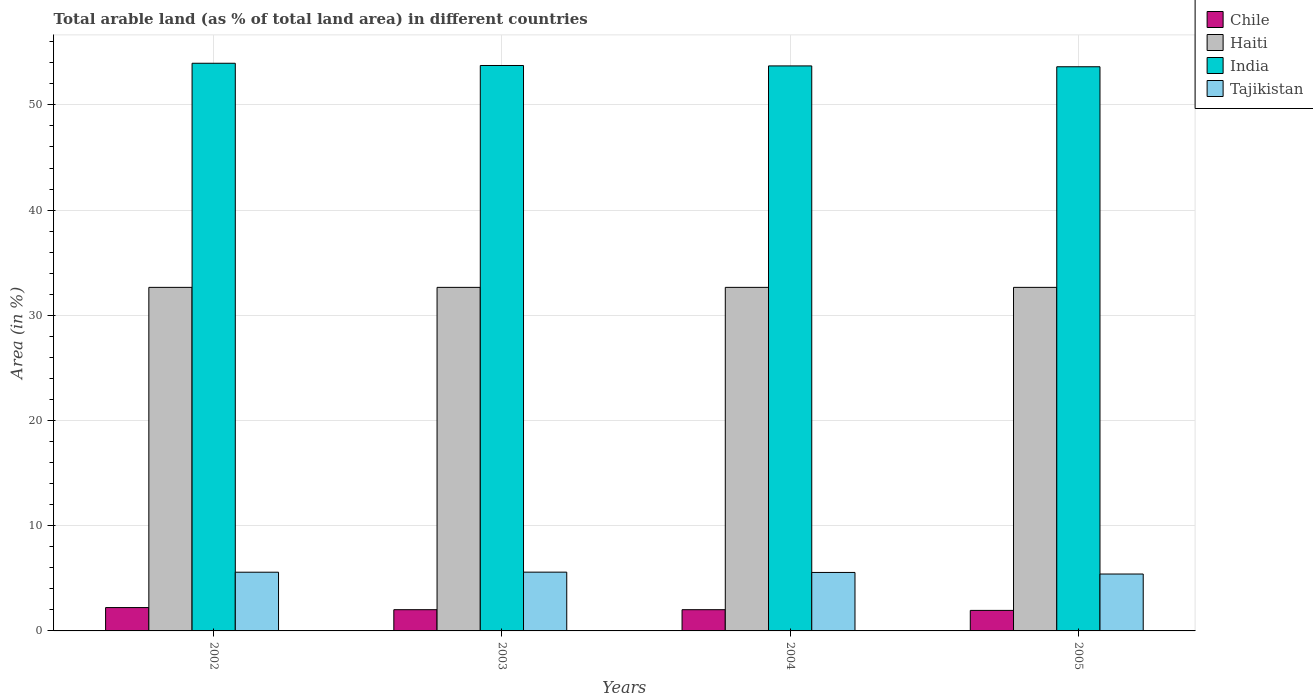How many groups of bars are there?
Offer a terse response. 4. Are the number of bars per tick equal to the number of legend labels?
Give a very brief answer. Yes. Are the number of bars on each tick of the X-axis equal?
Provide a short and direct response. Yes. How many bars are there on the 4th tick from the left?
Offer a terse response. 4. How many bars are there on the 3rd tick from the right?
Your answer should be compact. 4. In how many cases, is the number of bars for a given year not equal to the number of legend labels?
Give a very brief answer. 0. What is the percentage of arable land in Chile in 2004?
Keep it short and to the point. 2.02. Across all years, what is the maximum percentage of arable land in Chile?
Provide a short and direct response. 2.22. Across all years, what is the minimum percentage of arable land in India?
Your answer should be very brief. 53.63. In which year was the percentage of arable land in Tajikistan minimum?
Offer a terse response. 2005. What is the total percentage of arable land in Chile in the graph?
Your answer should be compact. 8.2. What is the difference between the percentage of arable land in India in 2002 and that in 2003?
Your answer should be compact. 0.21. What is the difference between the percentage of arable land in Tajikistan in 2003 and the percentage of arable land in India in 2004?
Provide a short and direct response. -48.12. What is the average percentage of arable land in Chile per year?
Offer a very short reply. 2.05. In the year 2002, what is the difference between the percentage of arable land in Tajikistan and percentage of arable land in Haiti?
Ensure brevity in your answer.  -27.08. In how many years, is the percentage of arable land in Chile greater than 16 %?
Keep it short and to the point. 0. What is the ratio of the percentage of arable land in Chile in 2004 to that in 2005?
Ensure brevity in your answer.  1.03. What is the difference between the highest and the second highest percentage of arable land in Tajikistan?
Keep it short and to the point. 0.01. What does the 2nd bar from the left in 2002 represents?
Provide a succinct answer. Haiti. What does the 1st bar from the right in 2005 represents?
Your response must be concise. Tajikistan. Is it the case that in every year, the sum of the percentage of arable land in Haiti and percentage of arable land in India is greater than the percentage of arable land in Tajikistan?
Give a very brief answer. Yes. What is the difference between two consecutive major ticks on the Y-axis?
Offer a terse response. 10. Does the graph contain any zero values?
Ensure brevity in your answer.  No. Does the graph contain grids?
Offer a very short reply. Yes. Where does the legend appear in the graph?
Your answer should be very brief. Top right. How many legend labels are there?
Your answer should be very brief. 4. How are the legend labels stacked?
Give a very brief answer. Vertical. What is the title of the graph?
Offer a terse response. Total arable land (as % of total land area) in different countries. Does "Philippines" appear as one of the legend labels in the graph?
Your response must be concise. No. What is the label or title of the Y-axis?
Provide a short and direct response. Area (in %). What is the Area (in %) of Chile in 2002?
Your answer should be very brief. 2.22. What is the Area (in %) of Haiti in 2002?
Your answer should be very brief. 32.66. What is the Area (in %) of India in 2002?
Ensure brevity in your answer.  53.96. What is the Area (in %) of Tajikistan in 2002?
Offer a very short reply. 5.58. What is the Area (in %) of Chile in 2003?
Your answer should be very brief. 2.02. What is the Area (in %) of Haiti in 2003?
Give a very brief answer. 32.66. What is the Area (in %) in India in 2003?
Your response must be concise. 53.75. What is the Area (in %) in Tajikistan in 2003?
Keep it short and to the point. 5.59. What is the Area (in %) of Chile in 2004?
Offer a very short reply. 2.02. What is the Area (in %) of Haiti in 2004?
Give a very brief answer. 32.66. What is the Area (in %) of India in 2004?
Offer a very short reply. 53.71. What is the Area (in %) of Tajikistan in 2004?
Provide a succinct answer. 5.56. What is the Area (in %) in Chile in 2005?
Make the answer very short. 1.95. What is the Area (in %) of Haiti in 2005?
Ensure brevity in your answer.  32.66. What is the Area (in %) in India in 2005?
Keep it short and to the point. 53.63. What is the Area (in %) of Tajikistan in 2005?
Your answer should be very brief. 5.41. Across all years, what is the maximum Area (in %) in Chile?
Provide a short and direct response. 2.22. Across all years, what is the maximum Area (in %) in Haiti?
Offer a very short reply. 32.66. Across all years, what is the maximum Area (in %) of India?
Keep it short and to the point. 53.96. Across all years, what is the maximum Area (in %) in Tajikistan?
Keep it short and to the point. 5.59. Across all years, what is the minimum Area (in %) in Chile?
Provide a short and direct response. 1.95. Across all years, what is the minimum Area (in %) of Haiti?
Provide a short and direct response. 32.66. Across all years, what is the minimum Area (in %) in India?
Make the answer very short. 53.63. Across all years, what is the minimum Area (in %) of Tajikistan?
Offer a very short reply. 5.41. What is the total Area (in %) in Chile in the graph?
Keep it short and to the point. 8.2. What is the total Area (in %) of Haiti in the graph?
Provide a succinct answer. 130.62. What is the total Area (in %) in India in the graph?
Provide a short and direct response. 215.04. What is the total Area (in %) of Tajikistan in the graph?
Provide a short and direct response. 22.13. What is the difference between the Area (in %) in Chile in 2002 and that in 2003?
Give a very brief answer. 0.2. What is the difference between the Area (in %) of India in 2002 and that in 2003?
Give a very brief answer. 0.21. What is the difference between the Area (in %) of Tajikistan in 2002 and that in 2003?
Your answer should be very brief. -0.01. What is the difference between the Area (in %) of Chile in 2002 and that in 2004?
Provide a succinct answer. 0.2. What is the difference between the Area (in %) of India in 2002 and that in 2004?
Provide a succinct answer. 0.25. What is the difference between the Area (in %) of Tajikistan in 2002 and that in 2004?
Provide a succinct answer. 0.02. What is the difference between the Area (in %) in Chile in 2002 and that in 2005?
Offer a terse response. 0.27. What is the difference between the Area (in %) of Haiti in 2002 and that in 2005?
Offer a terse response. 0. What is the difference between the Area (in %) in India in 2002 and that in 2005?
Offer a very short reply. 0.33. What is the difference between the Area (in %) of Tajikistan in 2002 and that in 2005?
Provide a succinct answer. 0.17. What is the difference between the Area (in %) of Chile in 2003 and that in 2004?
Provide a succinct answer. 0. What is the difference between the Area (in %) of India in 2003 and that in 2004?
Provide a succinct answer. 0.04. What is the difference between the Area (in %) in Tajikistan in 2003 and that in 2004?
Offer a terse response. 0.03. What is the difference between the Area (in %) of Chile in 2003 and that in 2005?
Your response must be concise. 0.07. What is the difference between the Area (in %) in India in 2003 and that in 2005?
Give a very brief answer. 0.12. What is the difference between the Area (in %) in Tajikistan in 2003 and that in 2005?
Offer a terse response. 0.18. What is the difference between the Area (in %) in Chile in 2004 and that in 2005?
Ensure brevity in your answer.  0.07. What is the difference between the Area (in %) of India in 2004 and that in 2005?
Your answer should be compact. 0.08. What is the difference between the Area (in %) of Tajikistan in 2004 and that in 2005?
Keep it short and to the point. 0.15. What is the difference between the Area (in %) of Chile in 2002 and the Area (in %) of Haiti in 2003?
Give a very brief answer. -30.44. What is the difference between the Area (in %) of Chile in 2002 and the Area (in %) of India in 2003?
Provide a succinct answer. -51.53. What is the difference between the Area (in %) in Chile in 2002 and the Area (in %) in Tajikistan in 2003?
Provide a succinct answer. -3.37. What is the difference between the Area (in %) of Haiti in 2002 and the Area (in %) of India in 2003?
Provide a short and direct response. -21.09. What is the difference between the Area (in %) in Haiti in 2002 and the Area (in %) in Tajikistan in 2003?
Give a very brief answer. 27.07. What is the difference between the Area (in %) of India in 2002 and the Area (in %) of Tajikistan in 2003?
Give a very brief answer. 48.37. What is the difference between the Area (in %) of Chile in 2002 and the Area (in %) of Haiti in 2004?
Provide a succinct answer. -30.44. What is the difference between the Area (in %) of Chile in 2002 and the Area (in %) of India in 2004?
Provide a short and direct response. -51.49. What is the difference between the Area (in %) of Chile in 2002 and the Area (in %) of Tajikistan in 2004?
Your answer should be compact. -3.34. What is the difference between the Area (in %) of Haiti in 2002 and the Area (in %) of India in 2004?
Provide a short and direct response. -21.05. What is the difference between the Area (in %) of Haiti in 2002 and the Area (in %) of Tajikistan in 2004?
Offer a very short reply. 27.1. What is the difference between the Area (in %) in India in 2002 and the Area (in %) in Tajikistan in 2004?
Offer a terse response. 48.4. What is the difference between the Area (in %) of Chile in 2002 and the Area (in %) of Haiti in 2005?
Your answer should be compact. -30.44. What is the difference between the Area (in %) in Chile in 2002 and the Area (in %) in India in 2005?
Offer a very short reply. -51.41. What is the difference between the Area (in %) of Chile in 2002 and the Area (in %) of Tajikistan in 2005?
Provide a short and direct response. -3.19. What is the difference between the Area (in %) of Haiti in 2002 and the Area (in %) of India in 2005?
Offer a terse response. -20.97. What is the difference between the Area (in %) in Haiti in 2002 and the Area (in %) in Tajikistan in 2005?
Make the answer very short. 27.25. What is the difference between the Area (in %) in India in 2002 and the Area (in %) in Tajikistan in 2005?
Offer a terse response. 48.55. What is the difference between the Area (in %) of Chile in 2003 and the Area (in %) of Haiti in 2004?
Offer a very short reply. -30.64. What is the difference between the Area (in %) in Chile in 2003 and the Area (in %) in India in 2004?
Offer a very short reply. -51.69. What is the difference between the Area (in %) in Chile in 2003 and the Area (in %) in Tajikistan in 2004?
Keep it short and to the point. -3.54. What is the difference between the Area (in %) of Haiti in 2003 and the Area (in %) of India in 2004?
Provide a short and direct response. -21.05. What is the difference between the Area (in %) in Haiti in 2003 and the Area (in %) in Tajikistan in 2004?
Provide a short and direct response. 27.1. What is the difference between the Area (in %) of India in 2003 and the Area (in %) of Tajikistan in 2004?
Offer a very short reply. 48.19. What is the difference between the Area (in %) of Chile in 2003 and the Area (in %) of Haiti in 2005?
Your response must be concise. -30.64. What is the difference between the Area (in %) of Chile in 2003 and the Area (in %) of India in 2005?
Make the answer very short. -51.61. What is the difference between the Area (in %) of Chile in 2003 and the Area (in %) of Tajikistan in 2005?
Give a very brief answer. -3.39. What is the difference between the Area (in %) in Haiti in 2003 and the Area (in %) in India in 2005?
Your response must be concise. -20.97. What is the difference between the Area (in %) in Haiti in 2003 and the Area (in %) in Tajikistan in 2005?
Your response must be concise. 27.25. What is the difference between the Area (in %) of India in 2003 and the Area (in %) of Tajikistan in 2005?
Give a very brief answer. 48.34. What is the difference between the Area (in %) of Chile in 2004 and the Area (in %) of Haiti in 2005?
Your answer should be very brief. -30.64. What is the difference between the Area (in %) in Chile in 2004 and the Area (in %) in India in 2005?
Provide a short and direct response. -51.61. What is the difference between the Area (in %) of Chile in 2004 and the Area (in %) of Tajikistan in 2005?
Offer a very short reply. -3.39. What is the difference between the Area (in %) in Haiti in 2004 and the Area (in %) in India in 2005?
Ensure brevity in your answer.  -20.97. What is the difference between the Area (in %) of Haiti in 2004 and the Area (in %) of Tajikistan in 2005?
Provide a succinct answer. 27.25. What is the difference between the Area (in %) of India in 2004 and the Area (in %) of Tajikistan in 2005?
Your answer should be very brief. 48.3. What is the average Area (in %) in Chile per year?
Make the answer very short. 2.05. What is the average Area (in %) in Haiti per year?
Keep it short and to the point. 32.66. What is the average Area (in %) of India per year?
Offer a very short reply. 53.76. What is the average Area (in %) of Tajikistan per year?
Your response must be concise. 5.53. In the year 2002, what is the difference between the Area (in %) of Chile and Area (in %) of Haiti?
Keep it short and to the point. -30.44. In the year 2002, what is the difference between the Area (in %) in Chile and Area (in %) in India?
Keep it short and to the point. -51.74. In the year 2002, what is the difference between the Area (in %) of Chile and Area (in %) of Tajikistan?
Your response must be concise. -3.36. In the year 2002, what is the difference between the Area (in %) in Haiti and Area (in %) in India?
Your response must be concise. -21.3. In the year 2002, what is the difference between the Area (in %) of Haiti and Area (in %) of Tajikistan?
Offer a terse response. 27.08. In the year 2002, what is the difference between the Area (in %) of India and Area (in %) of Tajikistan?
Offer a very short reply. 48.38. In the year 2003, what is the difference between the Area (in %) of Chile and Area (in %) of Haiti?
Make the answer very short. -30.64. In the year 2003, what is the difference between the Area (in %) in Chile and Area (in %) in India?
Ensure brevity in your answer.  -51.73. In the year 2003, what is the difference between the Area (in %) of Chile and Area (in %) of Tajikistan?
Your response must be concise. -3.57. In the year 2003, what is the difference between the Area (in %) of Haiti and Area (in %) of India?
Keep it short and to the point. -21.09. In the year 2003, what is the difference between the Area (in %) in Haiti and Area (in %) in Tajikistan?
Provide a succinct answer. 27.07. In the year 2003, what is the difference between the Area (in %) of India and Area (in %) of Tajikistan?
Provide a succinct answer. 48.16. In the year 2004, what is the difference between the Area (in %) in Chile and Area (in %) in Haiti?
Your answer should be compact. -30.64. In the year 2004, what is the difference between the Area (in %) in Chile and Area (in %) in India?
Your response must be concise. -51.69. In the year 2004, what is the difference between the Area (in %) of Chile and Area (in %) of Tajikistan?
Your response must be concise. -3.54. In the year 2004, what is the difference between the Area (in %) of Haiti and Area (in %) of India?
Offer a very short reply. -21.05. In the year 2004, what is the difference between the Area (in %) in Haiti and Area (in %) in Tajikistan?
Your answer should be very brief. 27.1. In the year 2004, what is the difference between the Area (in %) of India and Area (in %) of Tajikistan?
Provide a short and direct response. 48.15. In the year 2005, what is the difference between the Area (in %) of Chile and Area (in %) of Haiti?
Provide a short and direct response. -30.71. In the year 2005, what is the difference between the Area (in %) of Chile and Area (in %) of India?
Offer a very short reply. -51.68. In the year 2005, what is the difference between the Area (in %) of Chile and Area (in %) of Tajikistan?
Make the answer very short. -3.46. In the year 2005, what is the difference between the Area (in %) in Haiti and Area (in %) in India?
Provide a succinct answer. -20.97. In the year 2005, what is the difference between the Area (in %) of Haiti and Area (in %) of Tajikistan?
Make the answer very short. 27.25. In the year 2005, what is the difference between the Area (in %) of India and Area (in %) of Tajikistan?
Make the answer very short. 48.22. What is the ratio of the Area (in %) of Haiti in 2002 to that in 2004?
Your answer should be compact. 1. What is the ratio of the Area (in %) of India in 2002 to that in 2004?
Your answer should be very brief. 1. What is the ratio of the Area (in %) in Chile in 2002 to that in 2005?
Offer a terse response. 1.14. What is the ratio of the Area (in %) in India in 2002 to that in 2005?
Your answer should be compact. 1.01. What is the ratio of the Area (in %) in Tajikistan in 2002 to that in 2005?
Your response must be concise. 1.03. What is the ratio of the Area (in %) of Chile in 2003 to that in 2004?
Ensure brevity in your answer.  1. What is the ratio of the Area (in %) in Haiti in 2003 to that in 2004?
Provide a succinct answer. 1. What is the ratio of the Area (in %) in India in 2003 to that in 2004?
Give a very brief answer. 1. What is the ratio of the Area (in %) of Chile in 2003 to that in 2005?
Keep it short and to the point. 1.03. What is the ratio of the Area (in %) of Haiti in 2003 to that in 2005?
Offer a very short reply. 1. What is the ratio of the Area (in %) of India in 2003 to that in 2005?
Give a very brief answer. 1. What is the ratio of the Area (in %) of Tajikistan in 2003 to that in 2005?
Give a very brief answer. 1.03. What is the ratio of the Area (in %) in Chile in 2004 to that in 2005?
Provide a succinct answer. 1.03. What is the ratio of the Area (in %) of India in 2004 to that in 2005?
Provide a succinct answer. 1. What is the ratio of the Area (in %) of Tajikistan in 2004 to that in 2005?
Your answer should be very brief. 1.03. What is the difference between the highest and the second highest Area (in %) in Chile?
Offer a terse response. 0.2. What is the difference between the highest and the second highest Area (in %) in Haiti?
Your response must be concise. 0. What is the difference between the highest and the second highest Area (in %) in India?
Give a very brief answer. 0.21. What is the difference between the highest and the second highest Area (in %) in Tajikistan?
Give a very brief answer. 0.01. What is the difference between the highest and the lowest Area (in %) in Chile?
Ensure brevity in your answer.  0.27. What is the difference between the highest and the lowest Area (in %) of Haiti?
Give a very brief answer. 0. What is the difference between the highest and the lowest Area (in %) in India?
Offer a very short reply. 0.33. What is the difference between the highest and the lowest Area (in %) of Tajikistan?
Your response must be concise. 0.18. 